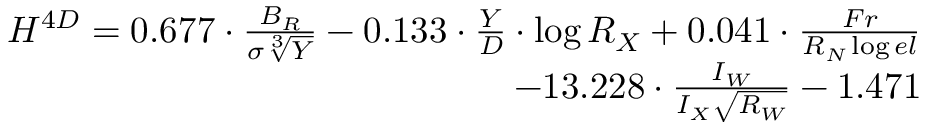Convert formula to latex. <formula><loc_0><loc_0><loc_500><loc_500>\begin{array} { r } { { H ^ { 4 D } = 0 . 6 7 7 \cdot \frac { B _ { R } } { \sigma \sqrt { [ } 3 ] { Y } } - 0 . 1 3 3 \cdot \frac { Y } { D } \cdot \log { R _ { X } } + 0 . 0 4 1 \cdot \frac { F r } { R _ { N } \log { e l } } } } \\ { { - 1 3 . 2 2 8 \cdot \frac { I _ { W } } { I _ { X } \sqrt { R _ { W } } } - 1 . 4 7 1 } } \end{array}</formula> 